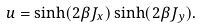Convert formula to latex. <formula><loc_0><loc_0><loc_500><loc_500>u = \sinh ( 2 \beta J _ { x } ) \sinh ( 2 \beta J _ { y } ) .</formula> 